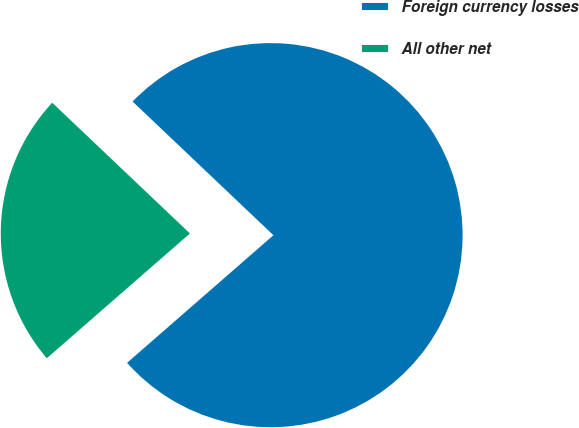<chart> <loc_0><loc_0><loc_500><loc_500><pie_chart><fcel>Foreign currency losses<fcel>All other net<nl><fcel>76.5%<fcel>23.5%<nl></chart> 